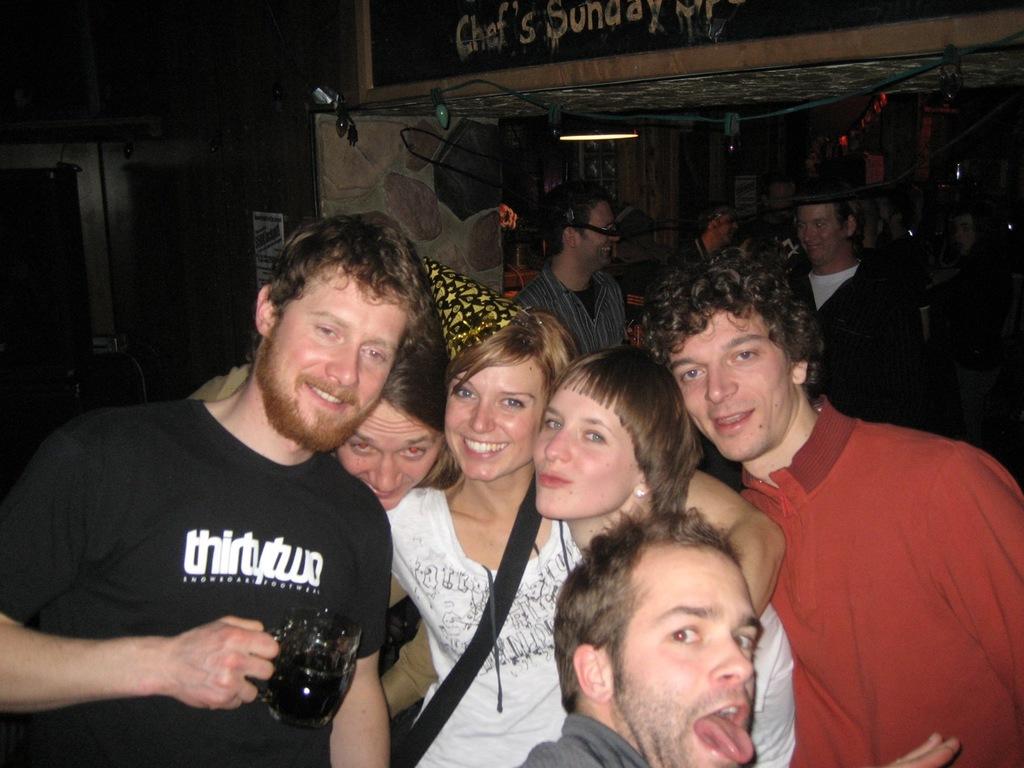What does the guys shirt say?
Your response must be concise. Thirtytwo. What is the first word on the sign at the top of the picture?
Your answer should be very brief. Chef. 